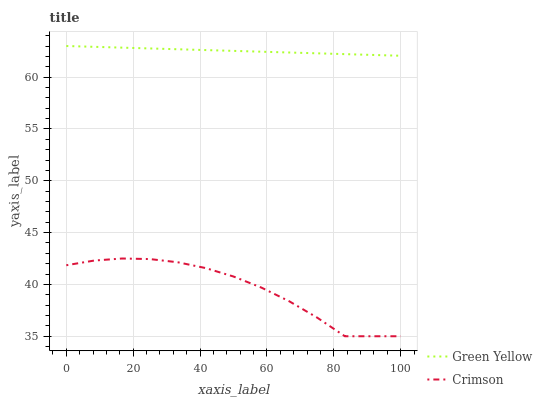Does Crimson have the minimum area under the curve?
Answer yes or no. Yes. Does Green Yellow have the maximum area under the curve?
Answer yes or no. Yes. Does Green Yellow have the minimum area under the curve?
Answer yes or no. No. Is Green Yellow the smoothest?
Answer yes or no. Yes. Is Crimson the roughest?
Answer yes or no. Yes. Is Green Yellow the roughest?
Answer yes or no. No. Does Crimson have the lowest value?
Answer yes or no. Yes. Does Green Yellow have the lowest value?
Answer yes or no. No. Does Green Yellow have the highest value?
Answer yes or no. Yes. Is Crimson less than Green Yellow?
Answer yes or no. Yes. Is Green Yellow greater than Crimson?
Answer yes or no. Yes. Does Crimson intersect Green Yellow?
Answer yes or no. No. 